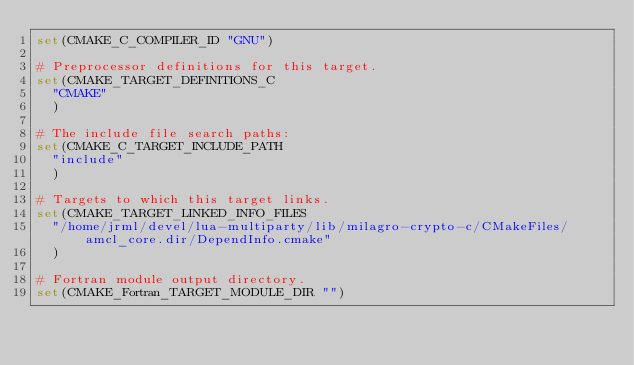<code> <loc_0><loc_0><loc_500><loc_500><_CMake_>set(CMAKE_C_COMPILER_ID "GNU")

# Preprocessor definitions for this target.
set(CMAKE_TARGET_DEFINITIONS_C
  "CMAKE"
  )

# The include file search paths:
set(CMAKE_C_TARGET_INCLUDE_PATH
  "include"
  )

# Targets to which this target links.
set(CMAKE_TARGET_LINKED_INFO_FILES
  "/home/jrml/devel/lua-multiparty/lib/milagro-crypto-c/CMakeFiles/amcl_core.dir/DependInfo.cmake"
  )

# Fortran module output directory.
set(CMAKE_Fortran_TARGET_MODULE_DIR "")
</code> 